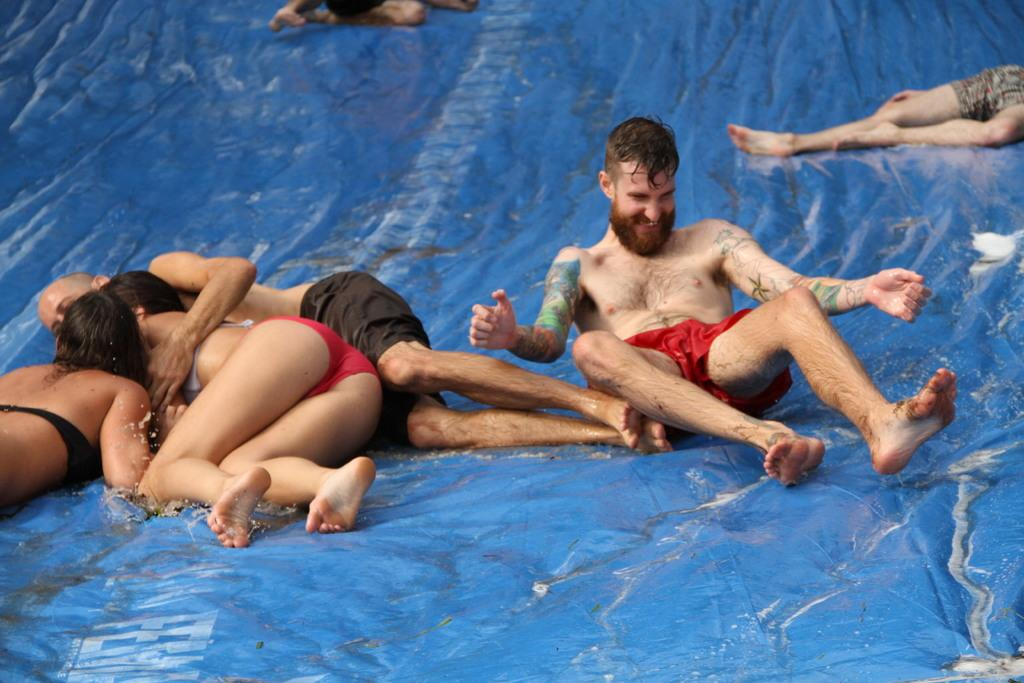Who or what is present in the image? There are people in the image. What are the people doing in the image? The people are sliding down on a blue cover. What type of scarecrow is present in the image? There is no scarecrow present in the image. What type of dress are the people wearing in the image? The provided facts do not mention any specific clothing, so we cannot determine the type of dress the people are wearing. 